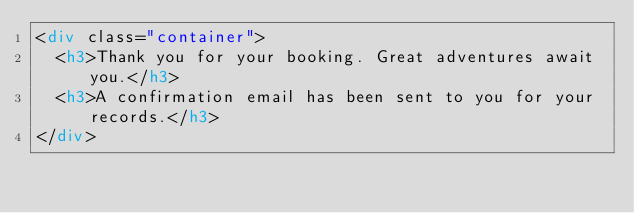<code> <loc_0><loc_0><loc_500><loc_500><_HTML_><div class="container">
	<h3>Thank you for your booking. Great adventures await you.</h3>
	<h3>A confirmation email has been sent to you for your records.</h3>
</div></code> 